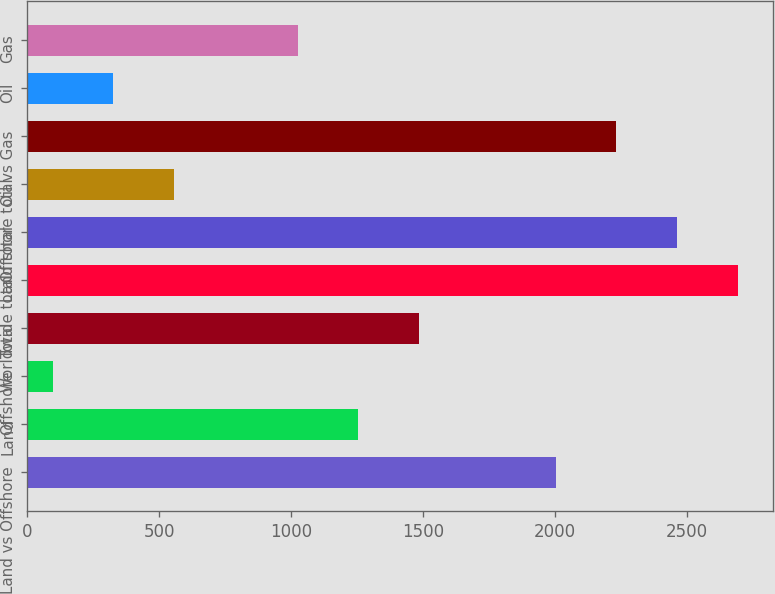Convert chart to OTSL. <chart><loc_0><loc_0><loc_500><loc_500><bar_chart><fcel>Land vs Offshore<fcel>Land<fcel>Offshore<fcel>Total<fcel>Worldwide total<fcel>Land total<fcel>Offshore total<fcel>Oil vs Gas<fcel>Oil<fcel>Gas<nl><fcel>2004<fcel>1254.8<fcel>97<fcel>1484.6<fcel>2693.4<fcel>2463.6<fcel>556.6<fcel>2233.8<fcel>326.8<fcel>1025<nl></chart> 